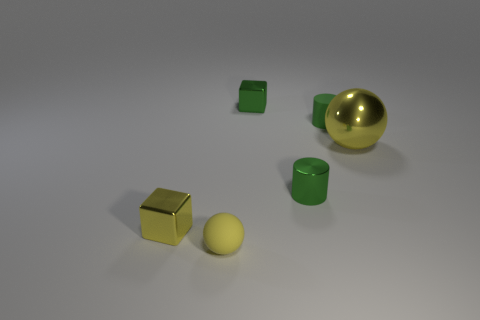Add 1 tiny shiny cylinders. How many objects exist? 7 Subtract all spheres. How many objects are left? 4 Add 6 large objects. How many large objects are left? 7 Add 5 tiny matte cylinders. How many tiny matte cylinders exist? 6 Subtract 0 yellow cylinders. How many objects are left? 6 Subtract all small yellow shiny objects. Subtract all tiny green matte cylinders. How many objects are left? 4 